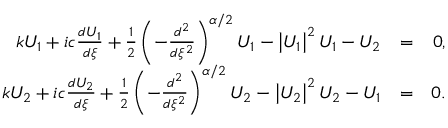<formula> <loc_0><loc_0><loc_500><loc_500>\begin{array} { r l r } { k U _ { 1 } + i c \frac { d U _ { 1 } } { d \xi } + \frac { 1 } { 2 } \left ( - \frac { d ^ { 2 } } { d \xi ^ { 2 } } \right ) ^ { \alpha / 2 } U _ { 1 } - \left | U _ { 1 } \right | ^ { 2 } U _ { 1 } - U _ { 2 } } & { = } & { 0 , } \\ { k U _ { 2 } + i c \frac { d U _ { 2 } } { d \xi } + \frac { 1 } { 2 } \left ( - \frac { d ^ { 2 } } { d \xi ^ { 2 } } \right ) ^ { \alpha / 2 } U _ { 2 } - \left | U _ { 2 } \right | ^ { 2 } U _ { 2 } - U _ { 1 } } & { = } & { 0 . } \end{array}</formula> 